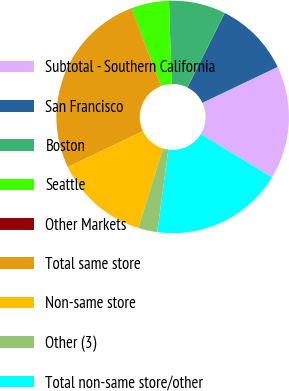<chart> <loc_0><loc_0><loc_500><loc_500><pie_chart><fcel>Subtotal - Southern California<fcel>San Francisco<fcel>Boston<fcel>Seattle<fcel>Other Markets<fcel>Total same store<fcel>Non-same store<fcel>Other (3)<fcel>Total non-same store/other<nl><fcel>15.78%<fcel>10.53%<fcel>7.9%<fcel>5.27%<fcel>0.02%<fcel>26.29%<fcel>13.15%<fcel>2.65%<fcel>18.41%<nl></chart> 